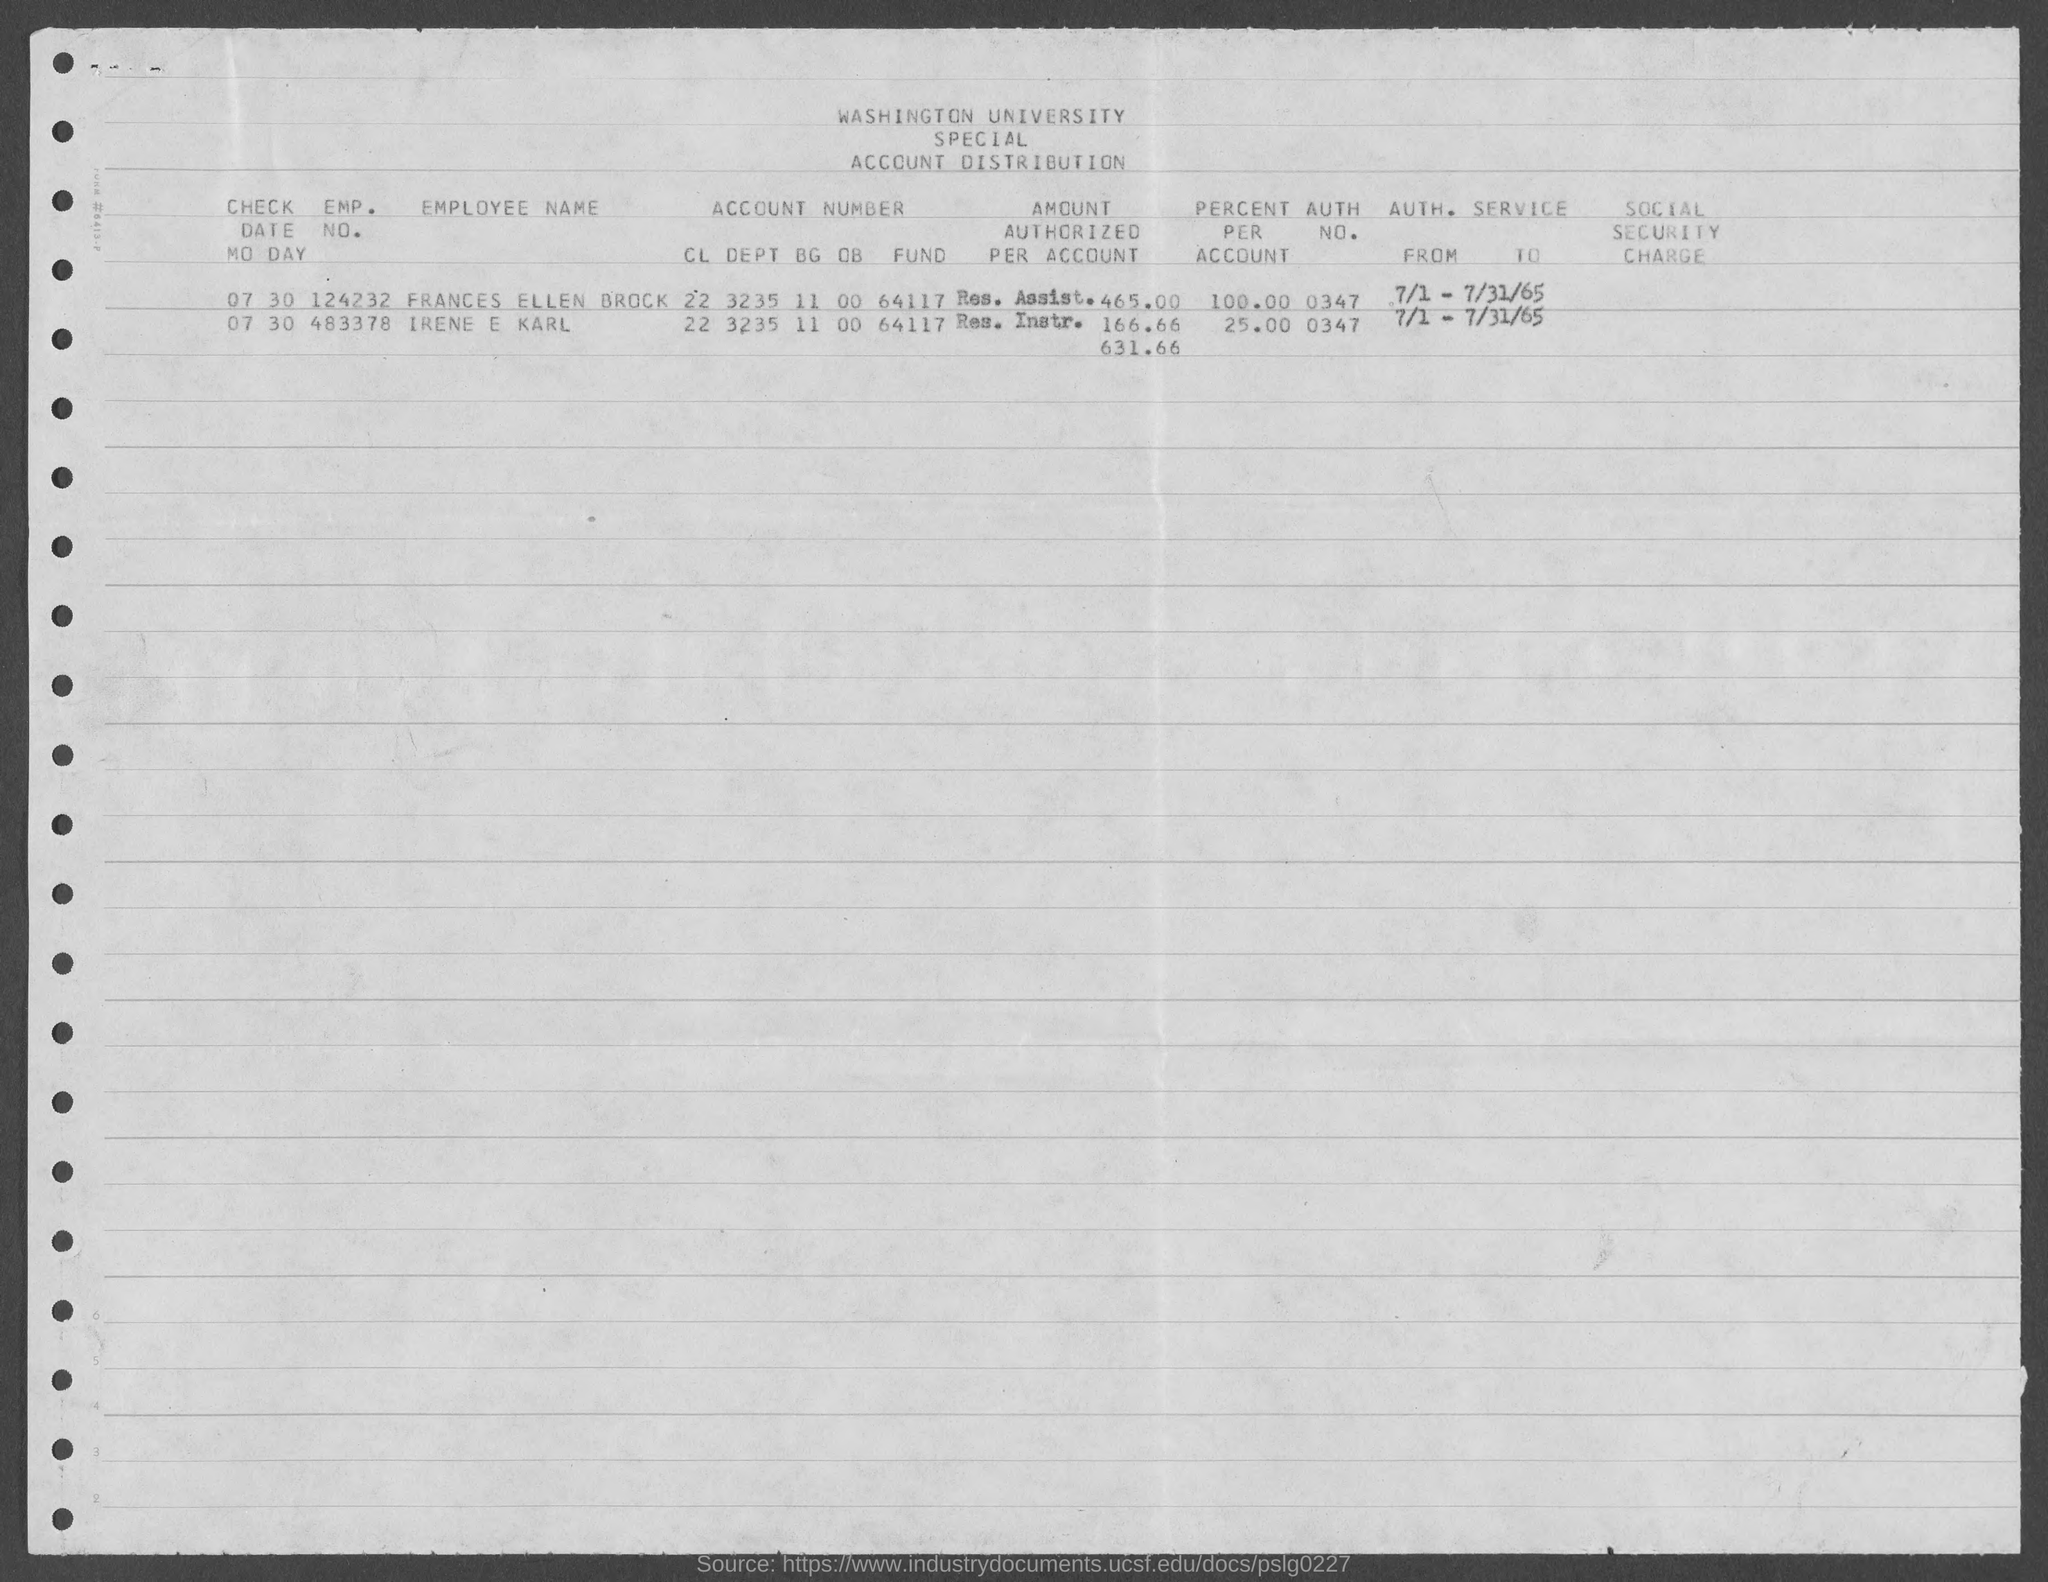What is the emp. no. of frances ellen brock as mentioned in the given form ?
Provide a short and direct response. 124232. What is the emp. no. of irene e karl  as mentioned in the given form ?
Provide a succinct answer. 483378. What is the auth. no. for frances ellen brock mentioned in the given page ?
Your answer should be compact. 0347. What is the value of percent per account for frances ellen brock as mentioned in the given form ?
Ensure brevity in your answer.  100. What is the value of percent per account for irene e karl as mentioned in the given form ?
Your answer should be compact. 25.00. 